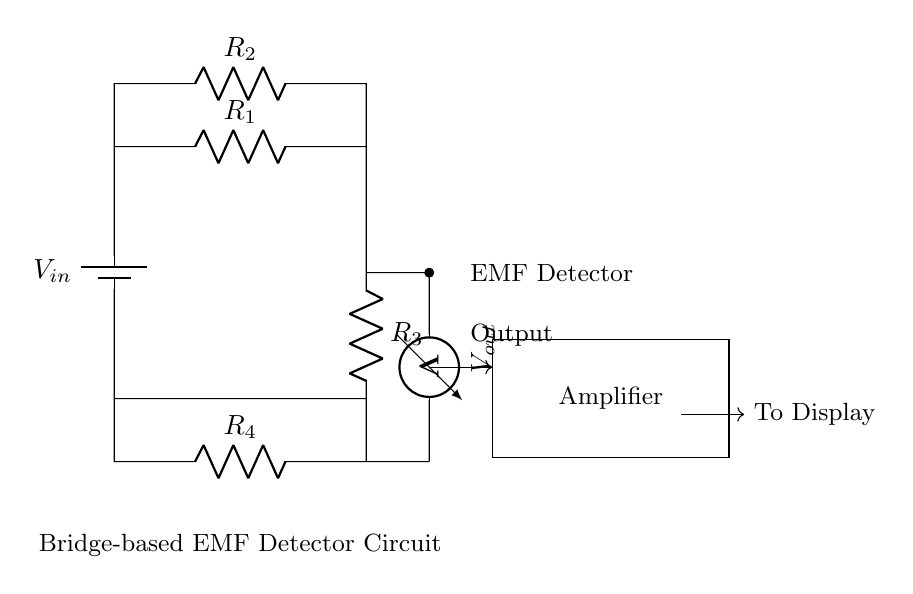What is the input voltage of the circuit? The input voltage, labeled as V_in, defines the voltage source supplying the circuit. It can be found by identifying the battery in the circuit diagram.
Answer: V_in What are the resistors in this circuit? The circuit includes four resistors labeled R_1, R_2, R_3, and R_4. They can be recognized by looking for the R labels and their placements in the diagram.
Answer: R_1, R_2, R_3, R_4 Which component measures the output voltage? The output voltage is measured by the voltmeter situated at the right side of the circuit. The voltmeter is defined with the label V_out.
Answer: Voltmeter How many resistors are in series? R_1, R_2, R_3, and R_4 are all resistors in the circuit. R_1 and R_3 are in series with a configuration leading to R_2 and R_4 respectively, but only R_2 and R_4 connect in parallel to R_1 and R_3 respectively. Therefore, only R_1 and R_3 are counted together.
Answer: Two What is the role of the amplifier in this circuit? The amplifier's role is to increase the signal strength from the EMF detector circuit, as indicated by its placement after the EMF detection output. It is essential for ensuring that the signal is strong enough for display.
Answer: Signal amplification What type of circuit is represented here? This circuit is a bridge-based EMF detector, characterized by its arrangement of resistors which are used to measure electromagnetic fields. This type allows for sensitive detection of EMF sources in the environment.
Answer: Bridge-based EMF detector 